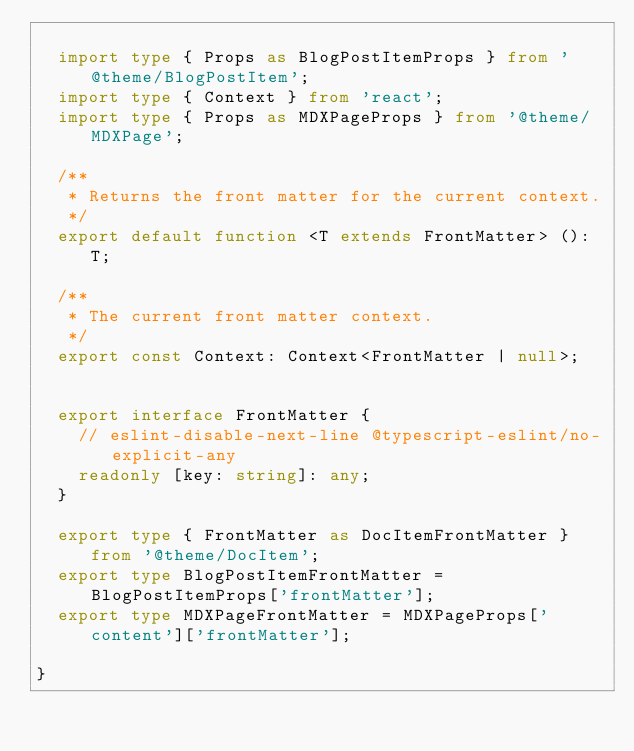Convert code to text. <code><loc_0><loc_0><loc_500><loc_500><_TypeScript_>
	import type { Props as BlogPostItemProps } from '@theme/BlogPostItem';
	import type { Context } from 'react';
	import type { Props as MDXPageProps } from '@theme/MDXPage';

	/**
	 * Returns the front matter for the current context.
	 */
	export default function <T extends FrontMatter> (): T;

	/**
	 * The current front matter context.
	 */
	export const Context: Context<FrontMatter | null>;


	export interface FrontMatter {
		// eslint-disable-next-line @typescript-eslint/no-explicit-any
		readonly [key: string]: any;
	}

	export type { FrontMatter as DocItemFrontMatter } from '@theme/DocItem';
	export type BlogPostItemFrontMatter = BlogPostItemProps['frontMatter'];
	export type MDXPageFrontMatter = MDXPageProps['content']['frontMatter'];

}
</code> 